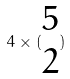<formula> <loc_0><loc_0><loc_500><loc_500>4 \times ( \begin{matrix} 5 \\ 2 \end{matrix} )</formula> 